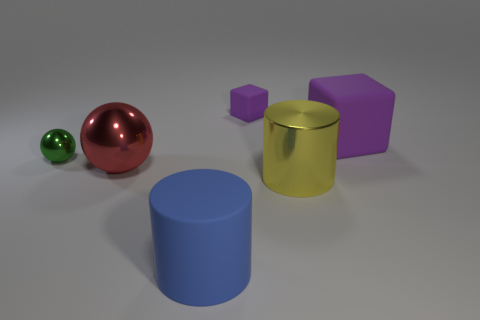Add 3 large shiny blocks. How many objects exist? 9 Subtract 0 cyan cylinders. How many objects are left? 6 Subtract all spheres. How many objects are left? 4 Subtract all yellow shiny objects. Subtract all small metallic objects. How many objects are left? 4 Add 3 red things. How many red things are left? 4 Add 3 cyan blocks. How many cyan blocks exist? 3 